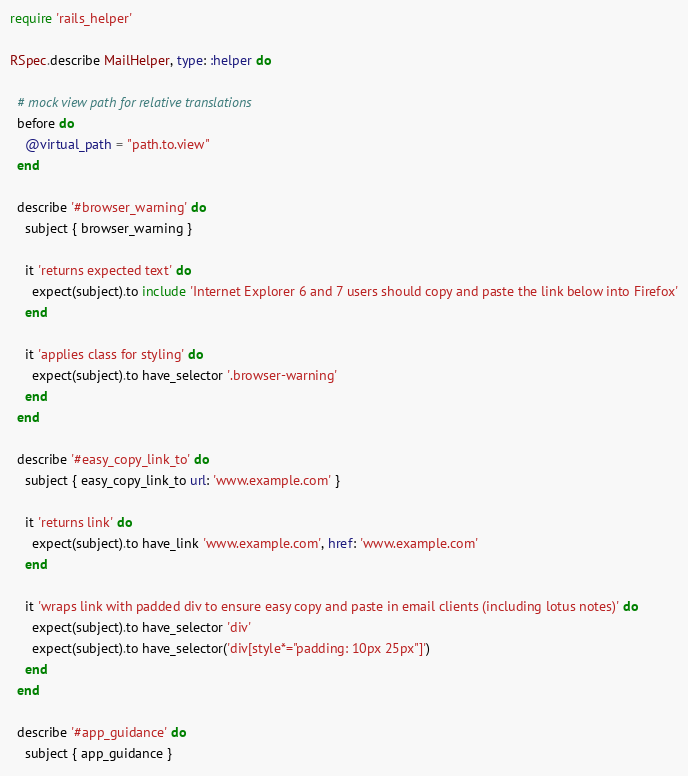<code> <loc_0><loc_0><loc_500><loc_500><_Ruby_>require 'rails_helper'

RSpec.describe MailHelper, type: :helper do

  # mock view path for relative translations
  before do
    @virtual_path = "path.to.view"
  end

  describe '#browser_warning' do
    subject { browser_warning }

    it 'returns expected text' do
      expect(subject).to include 'Internet Explorer 6 and 7 users should copy and paste the link below into Firefox'
    end

    it 'applies class for styling' do
      expect(subject).to have_selector '.browser-warning'
    end
  end

  describe '#easy_copy_link_to' do
    subject { easy_copy_link_to url: 'www.example.com' }

    it 'returns link' do
      expect(subject).to have_link 'www.example.com', href: 'www.example.com'
    end

    it 'wraps link with padded div to ensure easy copy and paste in email clients (including lotus notes)' do
      expect(subject).to have_selector 'div'
      expect(subject).to have_selector('div[style*="padding: 10px 25px"]')
    end
  end

  describe '#app_guidance' do
    subject { app_guidance }
</code> 